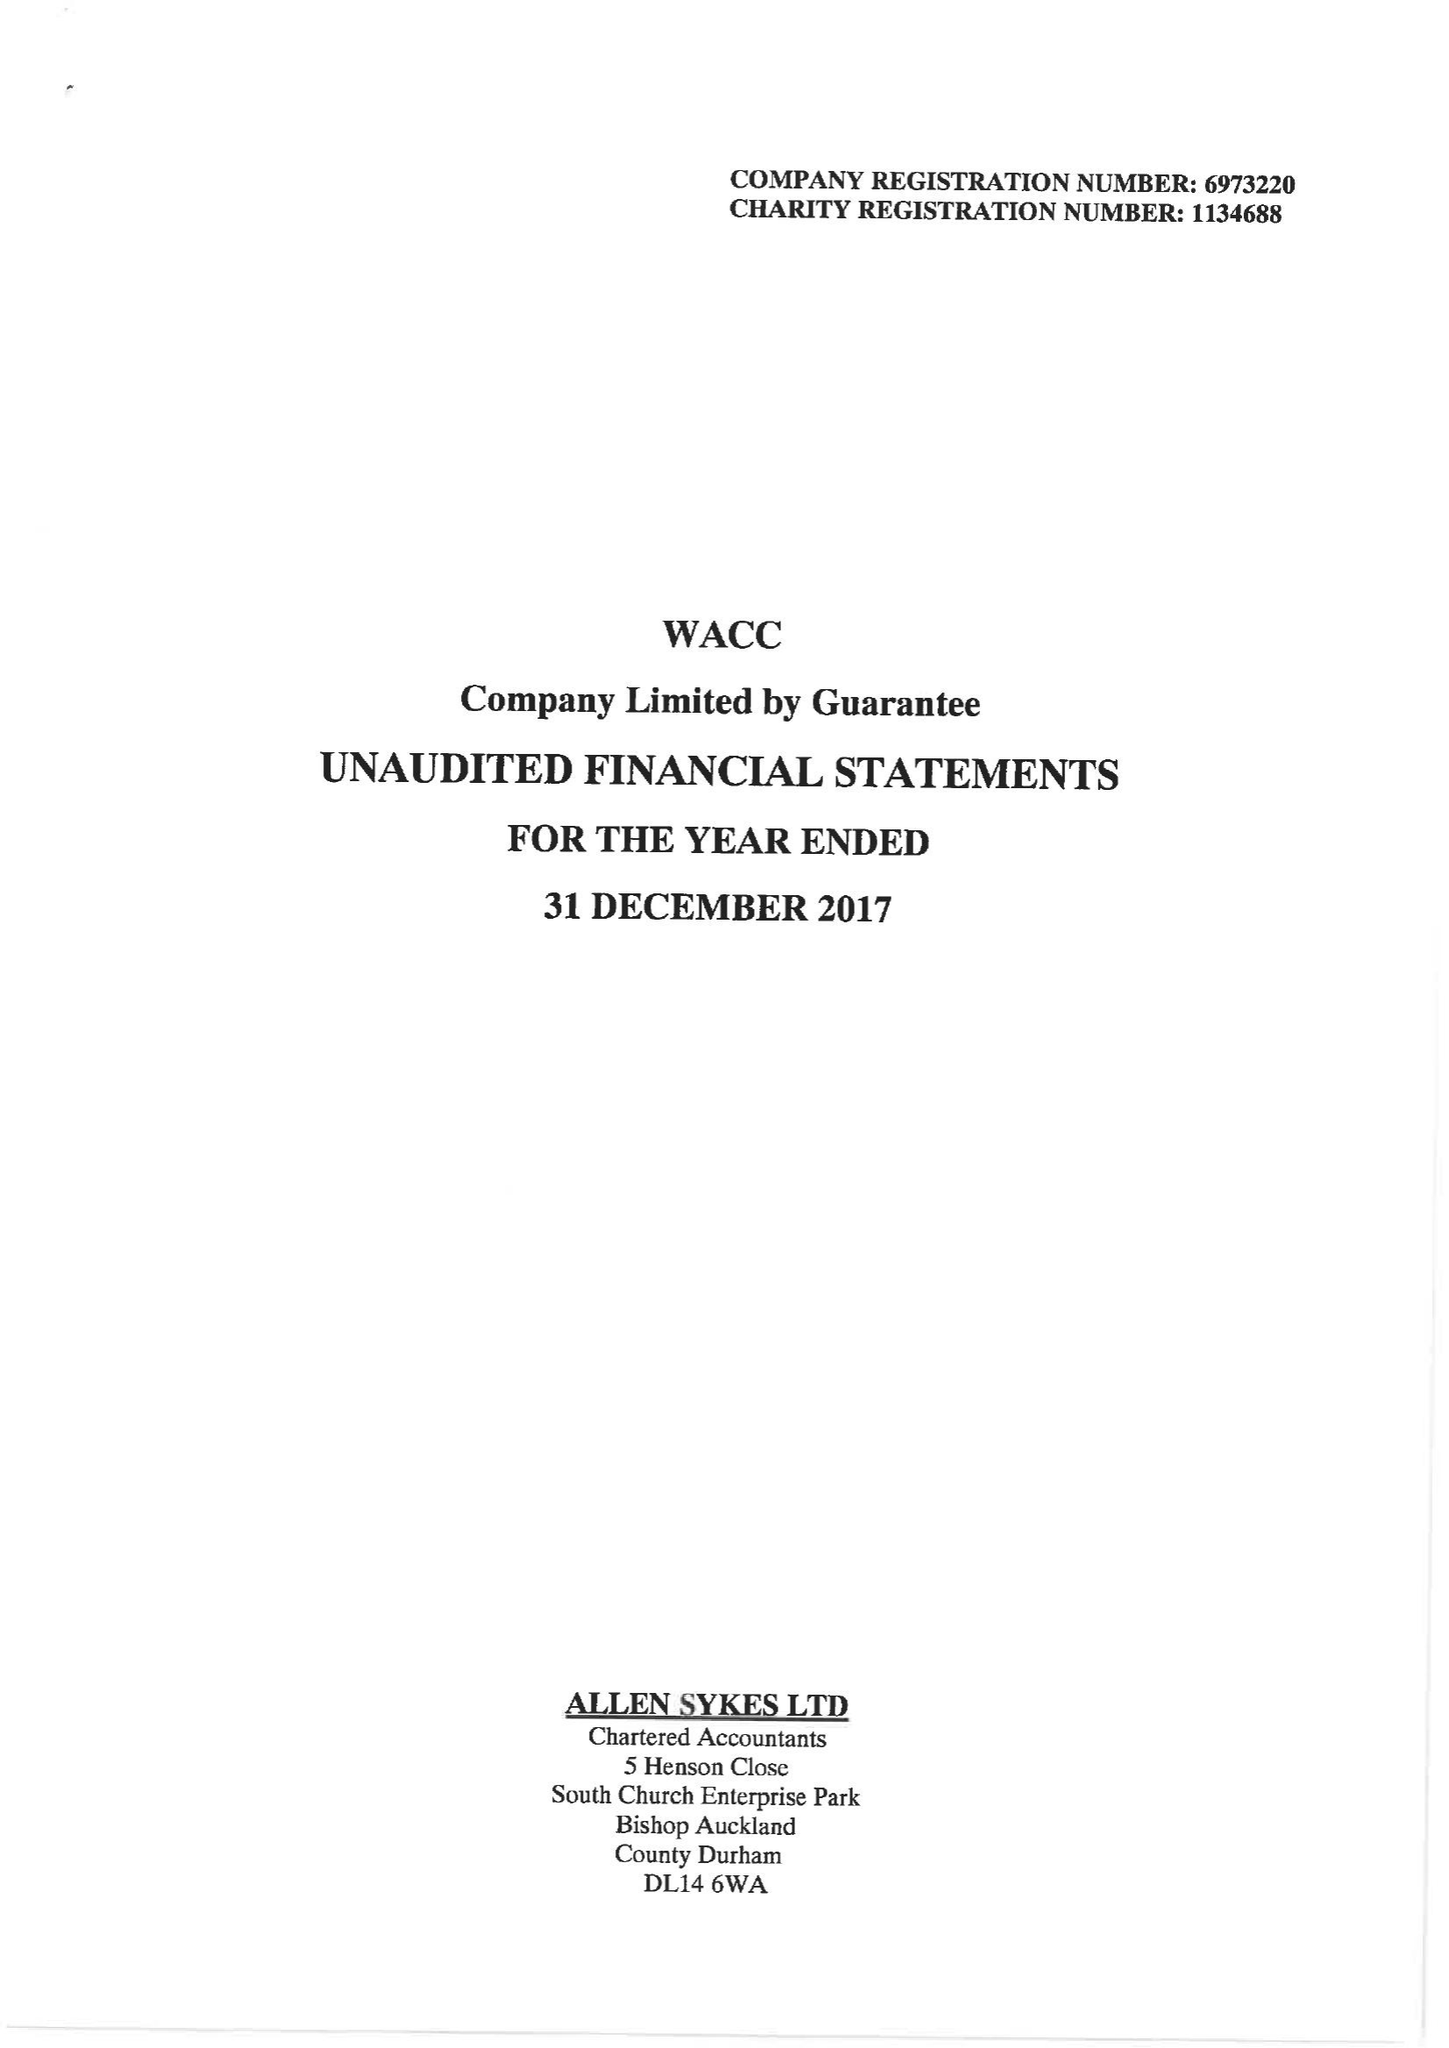What is the value for the charity_name?
Answer the question using a single word or phrase. West Auckland Community Church 